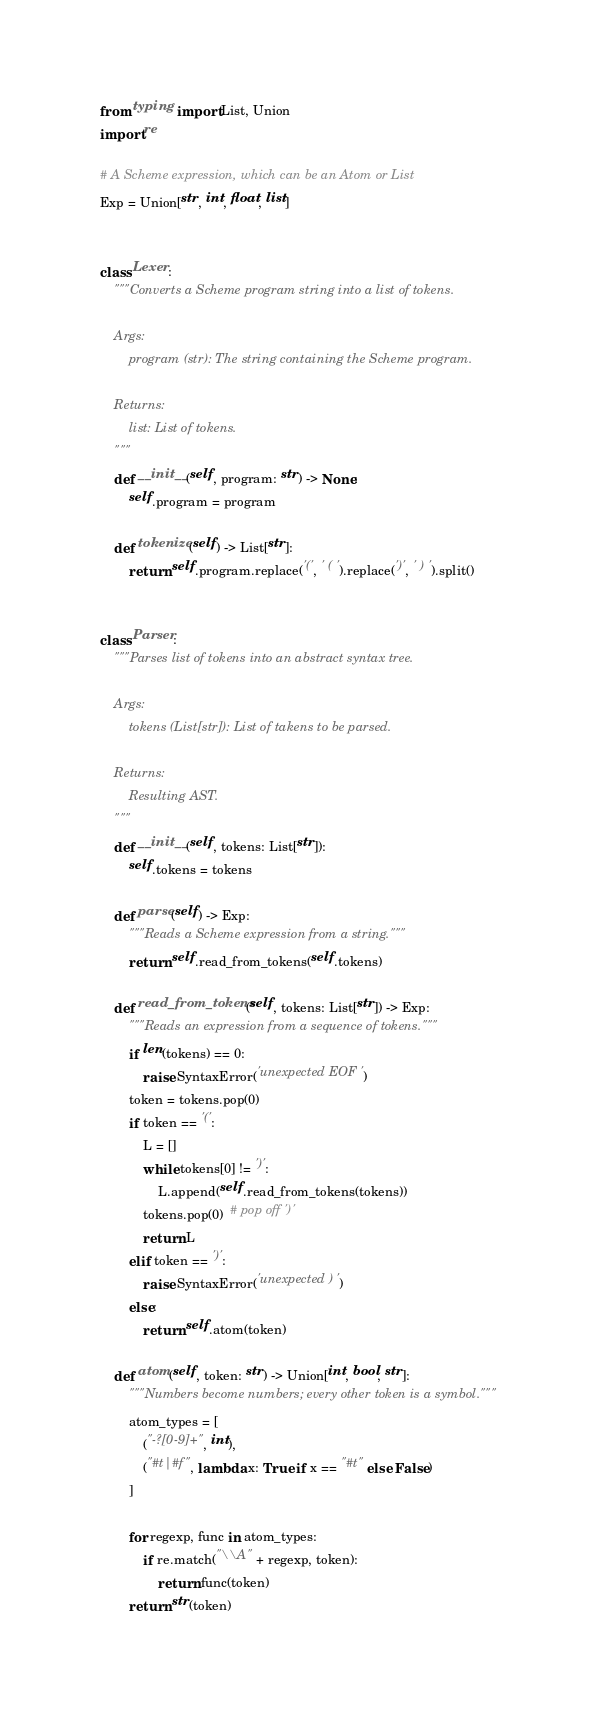Convert code to text. <code><loc_0><loc_0><loc_500><loc_500><_Python_>from typing import List, Union
import re

# A Scheme expression, which can be an Atom or List
Exp = Union[str, int, float, list]


class Lexer:
    """Converts a Scheme program string into a list of tokens.

    Args:
        program (str): The string containing the Scheme program.

    Returns:
        list: List of tokens.
    """
    def __init__(self, program: str) -> None:
        self.program = program

    def tokenize(self) -> List[str]:
        return self.program.replace('(', ' ( ').replace(')', ' ) ').split()


class Parser:
    """Parses list of tokens into an abstract syntax tree.

    Args:
        tokens (List[str]): List of takens to be parsed.

    Returns:
        Resulting AST.
    """
    def __init__(self, tokens: List[str]):
        self.tokens = tokens

    def parse(self) -> Exp:
        """Reads a Scheme expression from a string."""
        return self.read_from_tokens(self.tokens)

    def read_from_tokens(self, tokens: List[str]) -> Exp:
        """Reads an expression from a sequence of tokens."""
        if len(tokens) == 0:
            raise SyntaxError('unexpected EOF')
        token = tokens.pop(0)
        if token == '(':
            L = []
            while tokens[0] != ')':
                L.append(self.read_from_tokens(tokens))
            tokens.pop(0)  # pop off ')'
            return L
        elif token == ')':
            raise SyntaxError('unexpected )')
        else:
            return self.atom(token)

    def atom(self, token: str) -> Union[int, bool, str]:
        """Numbers become numbers; every other token is a symbol."""
        atom_types = [
            ("-?[0-9]+", int),
            ("#t|#f", lambda x: True if x == "#t" else False)
        ]

        for regexp, func in atom_types:
            if re.match("\\A" + regexp, token):
                return func(token)
        return str(token)
</code> 